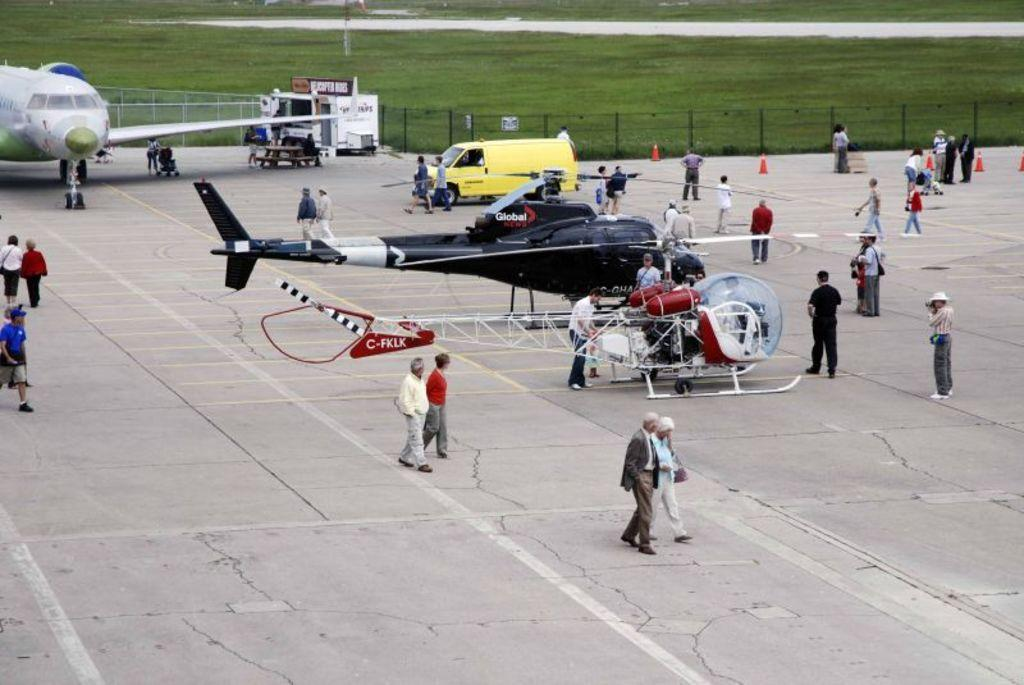What is the main subject of the image? The main subject of the image is aircrafts. Are there any people present in the image? Yes, there are people in the image. What other type of transportation can be seen in the image? There is a vehicle in the image. What type of natural environment is visible in the image? Grass is visible at the top of the image. What type of wealth is being traded between the aircrafts in the image? There is no indication of wealth or trade in the image; it simply shows aircrafts, people, a vehicle, and grass. 